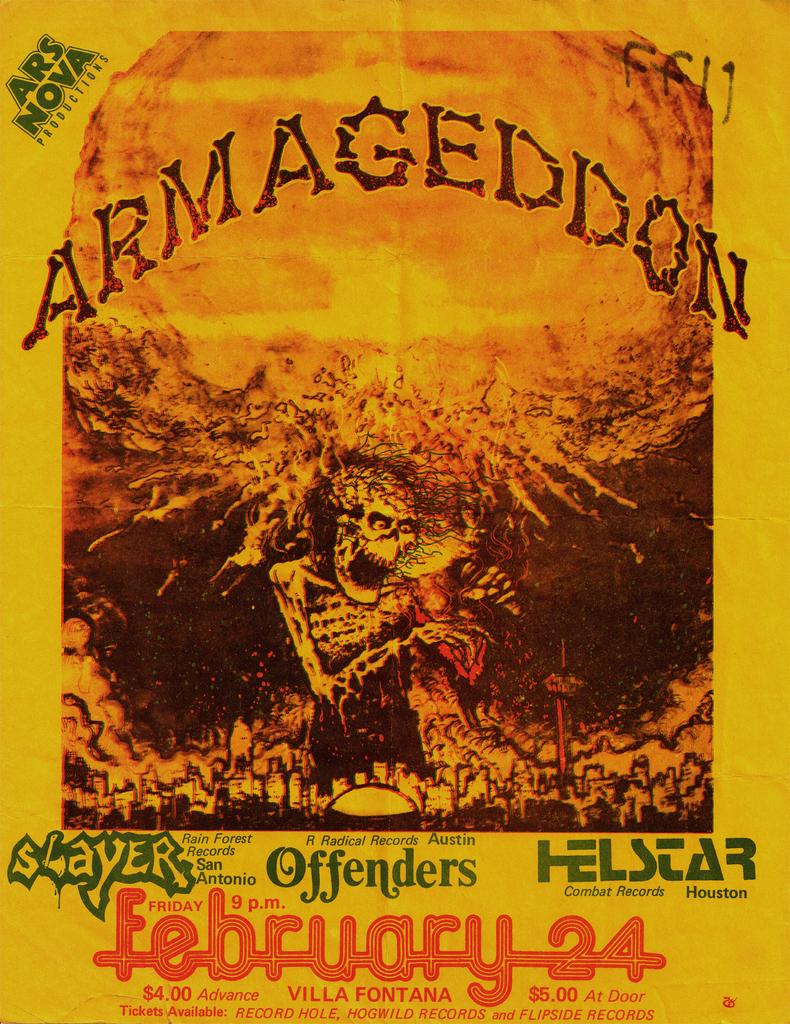What is present on the poster in the image? There is a poster in the image, which features both text and an image. Can you describe the image on the poster? Unfortunately, the provided facts do not give enough information to describe the image on the poster. What type of information is conveyed through the text on the poster? The provided facts do not give enough information to determine the content of the text on the poster. How many wounds can be seen on the elbow of the person in the image? There is no person present in the image, and therefore no wounds or elbows can be observed. 